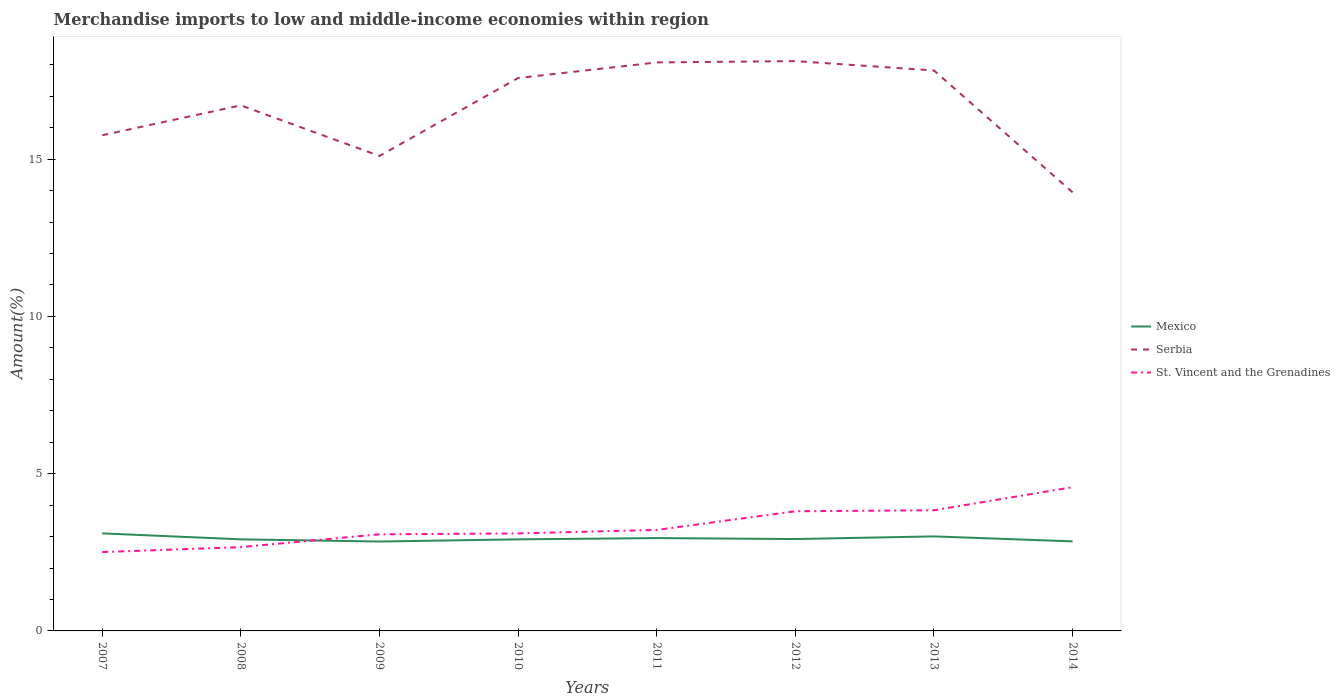Does the line corresponding to St. Vincent and the Grenadines intersect with the line corresponding to Serbia?
Your answer should be compact. No. Across all years, what is the maximum percentage of amount earned from merchandise imports in Serbia?
Your answer should be very brief. 13.95. In which year was the percentage of amount earned from merchandise imports in Serbia maximum?
Give a very brief answer. 2014. What is the total percentage of amount earned from merchandise imports in St. Vincent and the Grenadines in the graph?
Offer a terse response. -1.33. What is the difference between the highest and the second highest percentage of amount earned from merchandise imports in Serbia?
Your response must be concise. 4.17. What is the difference between the highest and the lowest percentage of amount earned from merchandise imports in Mexico?
Offer a terse response. 3. Is the percentage of amount earned from merchandise imports in St. Vincent and the Grenadines strictly greater than the percentage of amount earned from merchandise imports in Serbia over the years?
Provide a succinct answer. Yes. What is the difference between two consecutive major ticks on the Y-axis?
Your answer should be very brief. 5. Does the graph contain any zero values?
Make the answer very short. No. Where does the legend appear in the graph?
Keep it short and to the point. Center right. How many legend labels are there?
Ensure brevity in your answer.  3. How are the legend labels stacked?
Provide a succinct answer. Vertical. What is the title of the graph?
Your answer should be very brief. Merchandise imports to low and middle-income economies within region. What is the label or title of the X-axis?
Your response must be concise. Years. What is the label or title of the Y-axis?
Offer a terse response. Amount(%). What is the Amount(%) in Mexico in 2007?
Offer a very short reply. 3.1. What is the Amount(%) in Serbia in 2007?
Provide a short and direct response. 15.76. What is the Amount(%) of St. Vincent and the Grenadines in 2007?
Offer a terse response. 2.51. What is the Amount(%) in Mexico in 2008?
Provide a short and direct response. 2.91. What is the Amount(%) in Serbia in 2008?
Offer a very short reply. 16.71. What is the Amount(%) in St. Vincent and the Grenadines in 2008?
Provide a short and direct response. 2.66. What is the Amount(%) of Mexico in 2009?
Make the answer very short. 2.84. What is the Amount(%) in Serbia in 2009?
Provide a succinct answer. 15.1. What is the Amount(%) in St. Vincent and the Grenadines in 2009?
Make the answer very short. 3.07. What is the Amount(%) of Mexico in 2010?
Keep it short and to the point. 2.91. What is the Amount(%) in Serbia in 2010?
Make the answer very short. 17.58. What is the Amount(%) of St. Vincent and the Grenadines in 2010?
Keep it short and to the point. 3.1. What is the Amount(%) in Mexico in 2011?
Offer a very short reply. 2.95. What is the Amount(%) in Serbia in 2011?
Your answer should be compact. 18.07. What is the Amount(%) of St. Vincent and the Grenadines in 2011?
Offer a terse response. 3.21. What is the Amount(%) of Mexico in 2012?
Your answer should be compact. 2.92. What is the Amount(%) of Serbia in 2012?
Ensure brevity in your answer.  18.12. What is the Amount(%) in St. Vincent and the Grenadines in 2012?
Ensure brevity in your answer.  3.8. What is the Amount(%) in Mexico in 2013?
Offer a very short reply. 3.01. What is the Amount(%) of Serbia in 2013?
Your answer should be very brief. 17.82. What is the Amount(%) in St. Vincent and the Grenadines in 2013?
Your answer should be very brief. 3.84. What is the Amount(%) in Mexico in 2014?
Make the answer very short. 2.85. What is the Amount(%) in Serbia in 2014?
Keep it short and to the point. 13.95. What is the Amount(%) in St. Vincent and the Grenadines in 2014?
Ensure brevity in your answer.  4.57. Across all years, what is the maximum Amount(%) in Mexico?
Give a very brief answer. 3.1. Across all years, what is the maximum Amount(%) in Serbia?
Your answer should be compact. 18.12. Across all years, what is the maximum Amount(%) in St. Vincent and the Grenadines?
Your answer should be very brief. 4.57. Across all years, what is the minimum Amount(%) in Mexico?
Your response must be concise. 2.84. Across all years, what is the minimum Amount(%) of Serbia?
Give a very brief answer. 13.95. Across all years, what is the minimum Amount(%) in St. Vincent and the Grenadines?
Keep it short and to the point. 2.51. What is the total Amount(%) in Mexico in the graph?
Provide a short and direct response. 23.49. What is the total Amount(%) of Serbia in the graph?
Your answer should be compact. 133.1. What is the total Amount(%) in St. Vincent and the Grenadines in the graph?
Your answer should be very brief. 26.77. What is the difference between the Amount(%) of Mexico in 2007 and that in 2008?
Offer a terse response. 0.19. What is the difference between the Amount(%) of Serbia in 2007 and that in 2008?
Offer a terse response. -0.95. What is the difference between the Amount(%) of St. Vincent and the Grenadines in 2007 and that in 2008?
Make the answer very short. -0.16. What is the difference between the Amount(%) in Mexico in 2007 and that in 2009?
Your answer should be compact. 0.26. What is the difference between the Amount(%) of Serbia in 2007 and that in 2009?
Keep it short and to the point. 0.66. What is the difference between the Amount(%) in St. Vincent and the Grenadines in 2007 and that in 2009?
Give a very brief answer. -0.56. What is the difference between the Amount(%) in Mexico in 2007 and that in 2010?
Offer a terse response. 0.19. What is the difference between the Amount(%) of Serbia in 2007 and that in 2010?
Offer a very short reply. -1.82. What is the difference between the Amount(%) in St. Vincent and the Grenadines in 2007 and that in 2010?
Offer a very short reply. -0.59. What is the difference between the Amount(%) of Mexico in 2007 and that in 2011?
Your answer should be very brief. 0.15. What is the difference between the Amount(%) in Serbia in 2007 and that in 2011?
Give a very brief answer. -2.32. What is the difference between the Amount(%) of St. Vincent and the Grenadines in 2007 and that in 2011?
Your response must be concise. -0.7. What is the difference between the Amount(%) of Mexico in 2007 and that in 2012?
Keep it short and to the point. 0.18. What is the difference between the Amount(%) of Serbia in 2007 and that in 2012?
Provide a short and direct response. -2.36. What is the difference between the Amount(%) in St. Vincent and the Grenadines in 2007 and that in 2012?
Your answer should be compact. -1.3. What is the difference between the Amount(%) of Mexico in 2007 and that in 2013?
Make the answer very short. 0.1. What is the difference between the Amount(%) in Serbia in 2007 and that in 2013?
Your answer should be very brief. -2.06. What is the difference between the Amount(%) in St. Vincent and the Grenadines in 2007 and that in 2013?
Provide a succinct answer. -1.33. What is the difference between the Amount(%) in Mexico in 2007 and that in 2014?
Your response must be concise. 0.25. What is the difference between the Amount(%) in Serbia in 2007 and that in 2014?
Offer a very short reply. 1.81. What is the difference between the Amount(%) of St. Vincent and the Grenadines in 2007 and that in 2014?
Offer a very short reply. -2.06. What is the difference between the Amount(%) of Mexico in 2008 and that in 2009?
Make the answer very short. 0.07. What is the difference between the Amount(%) of Serbia in 2008 and that in 2009?
Provide a short and direct response. 1.61. What is the difference between the Amount(%) in St. Vincent and the Grenadines in 2008 and that in 2009?
Make the answer very short. -0.41. What is the difference between the Amount(%) of Mexico in 2008 and that in 2010?
Your answer should be very brief. -0. What is the difference between the Amount(%) of Serbia in 2008 and that in 2010?
Your response must be concise. -0.87. What is the difference between the Amount(%) in St. Vincent and the Grenadines in 2008 and that in 2010?
Provide a succinct answer. -0.44. What is the difference between the Amount(%) in Mexico in 2008 and that in 2011?
Keep it short and to the point. -0.04. What is the difference between the Amount(%) in Serbia in 2008 and that in 2011?
Your response must be concise. -1.37. What is the difference between the Amount(%) in St. Vincent and the Grenadines in 2008 and that in 2011?
Your response must be concise. -0.55. What is the difference between the Amount(%) of Mexico in 2008 and that in 2012?
Ensure brevity in your answer.  -0.01. What is the difference between the Amount(%) in Serbia in 2008 and that in 2012?
Your answer should be compact. -1.41. What is the difference between the Amount(%) of St. Vincent and the Grenadines in 2008 and that in 2012?
Your response must be concise. -1.14. What is the difference between the Amount(%) in Mexico in 2008 and that in 2013?
Provide a succinct answer. -0.09. What is the difference between the Amount(%) in Serbia in 2008 and that in 2013?
Offer a terse response. -1.11. What is the difference between the Amount(%) in St. Vincent and the Grenadines in 2008 and that in 2013?
Offer a terse response. -1.17. What is the difference between the Amount(%) of Mexico in 2008 and that in 2014?
Give a very brief answer. 0.06. What is the difference between the Amount(%) of Serbia in 2008 and that in 2014?
Offer a terse response. 2.76. What is the difference between the Amount(%) of St. Vincent and the Grenadines in 2008 and that in 2014?
Your answer should be very brief. -1.91. What is the difference between the Amount(%) in Mexico in 2009 and that in 2010?
Your response must be concise. -0.07. What is the difference between the Amount(%) in Serbia in 2009 and that in 2010?
Keep it short and to the point. -2.48. What is the difference between the Amount(%) in St. Vincent and the Grenadines in 2009 and that in 2010?
Your response must be concise. -0.03. What is the difference between the Amount(%) in Mexico in 2009 and that in 2011?
Offer a very short reply. -0.11. What is the difference between the Amount(%) of Serbia in 2009 and that in 2011?
Keep it short and to the point. -2.97. What is the difference between the Amount(%) in St. Vincent and the Grenadines in 2009 and that in 2011?
Ensure brevity in your answer.  -0.14. What is the difference between the Amount(%) in Mexico in 2009 and that in 2012?
Make the answer very short. -0.08. What is the difference between the Amount(%) of Serbia in 2009 and that in 2012?
Provide a succinct answer. -3.01. What is the difference between the Amount(%) of St. Vincent and the Grenadines in 2009 and that in 2012?
Your answer should be compact. -0.73. What is the difference between the Amount(%) in Mexico in 2009 and that in 2013?
Provide a succinct answer. -0.16. What is the difference between the Amount(%) of Serbia in 2009 and that in 2013?
Ensure brevity in your answer.  -2.72. What is the difference between the Amount(%) in St. Vincent and the Grenadines in 2009 and that in 2013?
Provide a short and direct response. -0.76. What is the difference between the Amount(%) of Mexico in 2009 and that in 2014?
Ensure brevity in your answer.  -0.01. What is the difference between the Amount(%) of Serbia in 2009 and that in 2014?
Give a very brief answer. 1.16. What is the difference between the Amount(%) in St. Vincent and the Grenadines in 2009 and that in 2014?
Provide a short and direct response. -1.5. What is the difference between the Amount(%) of Mexico in 2010 and that in 2011?
Keep it short and to the point. -0.04. What is the difference between the Amount(%) in Serbia in 2010 and that in 2011?
Give a very brief answer. -0.5. What is the difference between the Amount(%) in St. Vincent and the Grenadines in 2010 and that in 2011?
Ensure brevity in your answer.  -0.11. What is the difference between the Amount(%) of Mexico in 2010 and that in 2012?
Your response must be concise. -0.01. What is the difference between the Amount(%) of Serbia in 2010 and that in 2012?
Provide a succinct answer. -0.54. What is the difference between the Amount(%) in St. Vincent and the Grenadines in 2010 and that in 2012?
Offer a very short reply. -0.7. What is the difference between the Amount(%) of Mexico in 2010 and that in 2013?
Provide a succinct answer. -0.09. What is the difference between the Amount(%) of Serbia in 2010 and that in 2013?
Make the answer very short. -0.24. What is the difference between the Amount(%) of St. Vincent and the Grenadines in 2010 and that in 2013?
Offer a terse response. -0.74. What is the difference between the Amount(%) of Mexico in 2010 and that in 2014?
Provide a succinct answer. 0.06. What is the difference between the Amount(%) of Serbia in 2010 and that in 2014?
Provide a succinct answer. 3.63. What is the difference between the Amount(%) in St. Vincent and the Grenadines in 2010 and that in 2014?
Keep it short and to the point. -1.47. What is the difference between the Amount(%) in Mexico in 2011 and that in 2012?
Offer a very short reply. 0.03. What is the difference between the Amount(%) in Serbia in 2011 and that in 2012?
Your response must be concise. -0.04. What is the difference between the Amount(%) in St. Vincent and the Grenadines in 2011 and that in 2012?
Your answer should be compact. -0.59. What is the difference between the Amount(%) of Mexico in 2011 and that in 2013?
Your response must be concise. -0.05. What is the difference between the Amount(%) in Serbia in 2011 and that in 2013?
Offer a very short reply. 0.26. What is the difference between the Amount(%) in St. Vincent and the Grenadines in 2011 and that in 2013?
Provide a succinct answer. -0.63. What is the difference between the Amount(%) of Mexico in 2011 and that in 2014?
Provide a succinct answer. 0.1. What is the difference between the Amount(%) in Serbia in 2011 and that in 2014?
Offer a terse response. 4.13. What is the difference between the Amount(%) of St. Vincent and the Grenadines in 2011 and that in 2014?
Make the answer very short. -1.36. What is the difference between the Amount(%) in Mexico in 2012 and that in 2013?
Ensure brevity in your answer.  -0.08. What is the difference between the Amount(%) of Serbia in 2012 and that in 2013?
Your answer should be very brief. 0.3. What is the difference between the Amount(%) of St. Vincent and the Grenadines in 2012 and that in 2013?
Keep it short and to the point. -0.03. What is the difference between the Amount(%) in Mexico in 2012 and that in 2014?
Your answer should be compact. 0.07. What is the difference between the Amount(%) of Serbia in 2012 and that in 2014?
Your answer should be very brief. 4.17. What is the difference between the Amount(%) of St. Vincent and the Grenadines in 2012 and that in 2014?
Keep it short and to the point. -0.77. What is the difference between the Amount(%) of Mexico in 2013 and that in 2014?
Make the answer very short. 0.16. What is the difference between the Amount(%) in Serbia in 2013 and that in 2014?
Your response must be concise. 3.87. What is the difference between the Amount(%) of St. Vincent and the Grenadines in 2013 and that in 2014?
Provide a succinct answer. -0.73. What is the difference between the Amount(%) in Mexico in 2007 and the Amount(%) in Serbia in 2008?
Your answer should be very brief. -13.61. What is the difference between the Amount(%) of Mexico in 2007 and the Amount(%) of St. Vincent and the Grenadines in 2008?
Make the answer very short. 0.44. What is the difference between the Amount(%) of Serbia in 2007 and the Amount(%) of St. Vincent and the Grenadines in 2008?
Ensure brevity in your answer.  13.09. What is the difference between the Amount(%) of Mexico in 2007 and the Amount(%) of Serbia in 2009?
Ensure brevity in your answer.  -12. What is the difference between the Amount(%) of Mexico in 2007 and the Amount(%) of St. Vincent and the Grenadines in 2009?
Your answer should be very brief. 0.03. What is the difference between the Amount(%) in Serbia in 2007 and the Amount(%) in St. Vincent and the Grenadines in 2009?
Your answer should be compact. 12.69. What is the difference between the Amount(%) of Mexico in 2007 and the Amount(%) of Serbia in 2010?
Offer a terse response. -14.48. What is the difference between the Amount(%) in Mexico in 2007 and the Amount(%) in St. Vincent and the Grenadines in 2010?
Offer a terse response. 0. What is the difference between the Amount(%) in Serbia in 2007 and the Amount(%) in St. Vincent and the Grenadines in 2010?
Provide a short and direct response. 12.66. What is the difference between the Amount(%) in Mexico in 2007 and the Amount(%) in Serbia in 2011?
Ensure brevity in your answer.  -14.97. What is the difference between the Amount(%) of Mexico in 2007 and the Amount(%) of St. Vincent and the Grenadines in 2011?
Make the answer very short. -0.11. What is the difference between the Amount(%) in Serbia in 2007 and the Amount(%) in St. Vincent and the Grenadines in 2011?
Ensure brevity in your answer.  12.55. What is the difference between the Amount(%) in Mexico in 2007 and the Amount(%) in Serbia in 2012?
Ensure brevity in your answer.  -15.01. What is the difference between the Amount(%) of Mexico in 2007 and the Amount(%) of St. Vincent and the Grenadines in 2012?
Provide a short and direct response. -0.7. What is the difference between the Amount(%) in Serbia in 2007 and the Amount(%) in St. Vincent and the Grenadines in 2012?
Provide a succinct answer. 11.96. What is the difference between the Amount(%) in Mexico in 2007 and the Amount(%) in Serbia in 2013?
Make the answer very short. -14.72. What is the difference between the Amount(%) in Mexico in 2007 and the Amount(%) in St. Vincent and the Grenadines in 2013?
Provide a short and direct response. -0.74. What is the difference between the Amount(%) of Serbia in 2007 and the Amount(%) of St. Vincent and the Grenadines in 2013?
Provide a short and direct response. 11.92. What is the difference between the Amount(%) in Mexico in 2007 and the Amount(%) in Serbia in 2014?
Offer a very short reply. -10.84. What is the difference between the Amount(%) in Mexico in 2007 and the Amount(%) in St. Vincent and the Grenadines in 2014?
Your response must be concise. -1.47. What is the difference between the Amount(%) in Serbia in 2007 and the Amount(%) in St. Vincent and the Grenadines in 2014?
Provide a short and direct response. 11.19. What is the difference between the Amount(%) of Mexico in 2008 and the Amount(%) of Serbia in 2009?
Your answer should be compact. -12.19. What is the difference between the Amount(%) of Mexico in 2008 and the Amount(%) of St. Vincent and the Grenadines in 2009?
Provide a succinct answer. -0.16. What is the difference between the Amount(%) in Serbia in 2008 and the Amount(%) in St. Vincent and the Grenadines in 2009?
Keep it short and to the point. 13.64. What is the difference between the Amount(%) of Mexico in 2008 and the Amount(%) of Serbia in 2010?
Your answer should be compact. -14.67. What is the difference between the Amount(%) in Mexico in 2008 and the Amount(%) in St. Vincent and the Grenadines in 2010?
Offer a very short reply. -0.19. What is the difference between the Amount(%) of Serbia in 2008 and the Amount(%) of St. Vincent and the Grenadines in 2010?
Your answer should be very brief. 13.61. What is the difference between the Amount(%) in Mexico in 2008 and the Amount(%) in Serbia in 2011?
Offer a very short reply. -15.16. What is the difference between the Amount(%) of Mexico in 2008 and the Amount(%) of St. Vincent and the Grenadines in 2011?
Give a very brief answer. -0.3. What is the difference between the Amount(%) in Serbia in 2008 and the Amount(%) in St. Vincent and the Grenadines in 2011?
Make the answer very short. 13.5. What is the difference between the Amount(%) of Mexico in 2008 and the Amount(%) of Serbia in 2012?
Offer a very short reply. -15.2. What is the difference between the Amount(%) in Mexico in 2008 and the Amount(%) in St. Vincent and the Grenadines in 2012?
Provide a short and direct response. -0.89. What is the difference between the Amount(%) of Serbia in 2008 and the Amount(%) of St. Vincent and the Grenadines in 2012?
Your answer should be very brief. 12.9. What is the difference between the Amount(%) of Mexico in 2008 and the Amount(%) of Serbia in 2013?
Offer a terse response. -14.91. What is the difference between the Amount(%) of Mexico in 2008 and the Amount(%) of St. Vincent and the Grenadines in 2013?
Ensure brevity in your answer.  -0.93. What is the difference between the Amount(%) in Serbia in 2008 and the Amount(%) in St. Vincent and the Grenadines in 2013?
Ensure brevity in your answer.  12.87. What is the difference between the Amount(%) in Mexico in 2008 and the Amount(%) in Serbia in 2014?
Provide a succinct answer. -11.03. What is the difference between the Amount(%) in Mexico in 2008 and the Amount(%) in St. Vincent and the Grenadines in 2014?
Make the answer very short. -1.66. What is the difference between the Amount(%) of Serbia in 2008 and the Amount(%) of St. Vincent and the Grenadines in 2014?
Provide a short and direct response. 12.14. What is the difference between the Amount(%) of Mexico in 2009 and the Amount(%) of Serbia in 2010?
Keep it short and to the point. -14.74. What is the difference between the Amount(%) in Mexico in 2009 and the Amount(%) in St. Vincent and the Grenadines in 2010?
Offer a very short reply. -0.26. What is the difference between the Amount(%) in Serbia in 2009 and the Amount(%) in St. Vincent and the Grenadines in 2010?
Ensure brevity in your answer.  12. What is the difference between the Amount(%) of Mexico in 2009 and the Amount(%) of Serbia in 2011?
Ensure brevity in your answer.  -15.23. What is the difference between the Amount(%) of Mexico in 2009 and the Amount(%) of St. Vincent and the Grenadines in 2011?
Make the answer very short. -0.37. What is the difference between the Amount(%) in Serbia in 2009 and the Amount(%) in St. Vincent and the Grenadines in 2011?
Provide a succinct answer. 11.89. What is the difference between the Amount(%) of Mexico in 2009 and the Amount(%) of Serbia in 2012?
Offer a terse response. -15.27. What is the difference between the Amount(%) in Mexico in 2009 and the Amount(%) in St. Vincent and the Grenadines in 2012?
Offer a terse response. -0.96. What is the difference between the Amount(%) in Serbia in 2009 and the Amount(%) in St. Vincent and the Grenadines in 2012?
Your answer should be compact. 11.3. What is the difference between the Amount(%) of Mexico in 2009 and the Amount(%) of Serbia in 2013?
Your response must be concise. -14.98. What is the difference between the Amount(%) of Mexico in 2009 and the Amount(%) of St. Vincent and the Grenadines in 2013?
Provide a succinct answer. -0.99. What is the difference between the Amount(%) of Serbia in 2009 and the Amount(%) of St. Vincent and the Grenadines in 2013?
Keep it short and to the point. 11.26. What is the difference between the Amount(%) of Mexico in 2009 and the Amount(%) of Serbia in 2014?
Your response must be concise. -11.1. What is the difference between the Amount(%) in Mexico in 2009 and the Amount(%) in St. Vincent and the Grenadines in 2014?
Your answer should be very brief. -1.73. What is the difference between the Amount(%) in Serbia in 2009 and the Amount(%) in St. Vincent and the Grenadines in 2014?
Keep it short and to the point. 10.53. What is the difference between the Amount(%) of Mexico in 2010 and the Amount(%) of Serbia in 2011?
Offer a very short reply. -15.16. What is the difference between the Amount(%) of Mexico in 2010 and the Amount(%) of St. Vincent and the Grenadines in 2011?
Provide a short and direct response. -0.3. What is the difference between the Amount(%) in Serbia in 2010 and the Amount(%) in St. Vincent and the Grenadines in 2011?
Ensure brevity in your answer.  14.37. What is the difference between the Amount(%) of Mexico in 2010 and the Amount(%) of Serbia in 2012?
Provide a short and direct response. -15.2. What is the difference between the Amount(%) in Mexico in 2010 and the Amount(%) in St. Vincent and the Grenadines in 2012?
Make the answer very short. -0.89. What is the difference between the Amount(%) in Serbia in 2010 and the Amount(%) in St. Vincent and the Grenadines in 2012?
Keep it short and to the point. 13.77. What is the difference between the Amount(%) in Mexico in 2010 and the Amount(%) in Serbia in 2013?
Your answer should be compact. -14.91. What is the difference between the Amount(%) of Mexico in 2010 and the Amount(%) of St. Vincent and the Grenadines in 2013?
Provide a succinct answer. -0.93. What is the difference between the Amount(%) of Serbia in 2010 and the Amount(%) of St. Vincent and the Grenadines in 2013?
Your answer should be compact. 13.74. What is the difference between the Amount(%) of Mexico in 2010 and the Amount(%) of Serbia in 2014?
Offer a terse response. -11.03. What is the difference between the Amount(%) in Mexico in 2010 and the Amount(%) in St. Vincent and the Grenadines in 2014?
Offer a terse response. -1.66. What is the difference between the Amount(%) of Serbia in 2010 and the Amount(%) of St. Vincent and the Grenadines in 2014?
Your answer should be compact. 13.01. What is the difference between the Amount(%) of Mexico in 2011 and the Amount(%) of Serbia in 2012?
Provide a succinct answer. -15.16. What is the difference between the Amount(%) in Mexico in 2011 and the Amount(%) in St. Vincent and the Grenadines in 2012?
Offer a terse response. -0.85. What is the difference between the Amount(%) of Serbia in 2011 and the Amount(%) of St. Vincent and the Grenadines in 2012?
Your answer should be compact. 14.27. What is the difference between the Amount(%) of Mexico in 2011 and the Amount(%) of Serbia in 2013?
Offer a terse response. -14.87. What is the difference between the Amount(%) in Mexico in 2011 and the Amount(%) in St. Vincent and the Grenadines in 2013?
Offer a terse response. -0.89. What is the difference between the Amount(%) of Serbia in 2011 and the Amount(%) of St. Vincent and the Grenadines in 2013?
Your answer should be compact. 14.24. What is the difference between the Amount(%) in Mexico in 2011 and the Amount(%) in Serbia in 2014?
Make the answer very short. -10.99. What is the difference between the Amount(%) in Mexico in 2011 and the Amount(%) in St. Vincent and the Grenadines in 2014?
Offer a very short reply. -1.62. What is the difference between the Amount(%) of Serbia in 2011 and the Amount(%) of St. Vincent and the Grenadines in 2014?
Your answer should be very brief. 13.5. What is the difference between the Amount(%) in Mexico in 2012 and the Amount(%) in Serbia in 2013?
Give a very brief answer. -14.9. What is the difference between the Amount(%) in Mexico in 2012 and the Amount(%) in St. Vincent and the Grenadines in 2013?
Offer a terse response. -0.92. What is the difference between the Amount(%) of Serbia in 2012 and the Amount(%) of St. Vincent and the Grenadines in 2013?
Offer a very short reply. 14.28. What is the difference between the Amount(%) in Mexico in 2012 and the Amount(%) in Serbia in 2014?
Offer a very short reply. -11.02. What is the difference between the Amount(%) of Mexico in 2012 and the Amount(%) of St. Vincent and the Grenadines in 2014?
Make the answer very short. -1.65. What is the difference between the Amount(%) of Serbia in 2012 and the Amount(%) of St. Vincent and the Grenadines in 2014?
Your answer should be compact. 13.55. What is the difference between the Amount(%) in Mexico in 2013 and the Amount(%) in Serbia in 2014?
Ensure brevity in your answer.  -10.94. What is the difference between the Amount(%) of Mexico in 2013 and the Amount(%) of St. Vincent and the Grenadines in 2014?
Make the answer very short. -1.56. What is the difference between the Amount(%) in Serbia in 2013 and the Amount(%) in St. Vincent and the Grenadines in 2014?
Provide a succinct answer. 13.25. What is the average Amount(%) of Mexico per year?
Give a very brief answer. 2.94. What is the average Amount(%) in Serbia per year?
Offer a terse response. 16.64. What is the average Amount(%) in St. Vincent and the Grenadines per year?
Provide a succinct answer. 3.35. In the year 2007, what is the difference between the Amount(%) in Mexico and Amount(%) in Serbia?
Keep it short and to the point. -12.66. In the year 2007, what is the difference between the Amount(%) of Mexico and Amount(%) of St. Vincent and the Grenadines?
Your answer should be very brief. 0.59. In the year 2007, what is the difference between the Amount(%) of Serbia and Amount(%) of St. Vincent and the Grenadines?
Ensure brevity in your answer.  13.25. In the year 2008, what is the difference between the Amount(%) of Mexico and Amount(%) of Serbia?
Your answer should be compact. -13.8. In the year 2008, what is the difference between the Amount(%) of Mexico and Amount(%) of St. Vincent and the Grenadines?
Provide a succinct answer. 0.25. In the year 2008, what is the difference between the Amount(%) in Serbia and Amount(%) in St. Vincent and the Grenadines?
Provide a short and direct response. 14.04. In the year 2009, what is the difference between the Amount(%) in Mexico and Amount(%) in Serbia?
Your answer should be very brief. -12.26. In the year 2009, what is the difference between the Amount(%) in Mexico and Amount(%) in St. Vincent and the Grenadines?
Keep it short and to the point. -0.23. In the year 2009, what is the difference between the Amount(%) in Serbia and Amount(%) in St. Vincent and the Grenadines?
Provide a short and direct response. 12.03. In the year 2010, what is the difference between the Amount(%) in Mexico and Amount(%) in Serbia?
Make the answer very short. -14.67. In the year 2010, what is the difference between the Amount(%) of Mexico and Amount(%) of St. Vincent and the Grenadines?
Your response must be concise. -0.19. In the year 2010, what is the difference between the Amount(%) of Serbia and Amount(%) of St. Vincent and the Grenadines?
Keep it short and to the point. 14.48. In the year 2011, what is the difference between the Amount(%) of Mexico and Amount(%) of Serbia?
Offer a terse response. -15.12. In the year 2011, what is the difference between the Amount(%) of Mexico and Amount(%) of St. Vincent and the Grenadines?
Provide a short and direct response. -0.26. In the year 2011, what is the difference between the Amount(%) in Serbia and Amount(%) in St. Vincent and the Grenadines?
Provide a short and direct response. 14.86. In the year 2012, what is the difference between the Amount(%) of Mexico and Amount(%) of Serbia?
Your response must be concise. -15.2. In the year 2012, what is the difference between the Amount(%) of Mexico and Amount(%) of St. Vincent and the Grenadines?
Make the answer very short. -0.88. In the year 2012, what is the difference between the Amount(%) in Serbia and Amount(%) in St. Vincent and the Grenadines?
Ensure brevity in your answer.  14.31. In the year 2013, what is the difference between the Amount(%) of Mexico and Amount(%) of Serbia?
Keep it short and to the point. -14.81. In the year 2013, what is the difference between the Amount(%) of Mexico and Amount(%) of St. Vincent and the Grenadines?
Provide a short and direct response. -0.83. In the year 2013, what is the difference between the Amount(%) of Serbia and Amount(%) of St. Vincent and the Grenadines?
Keep it short and to the point. 13.98. In the year 2014, what is the difference between the Amount(%) in Mexico and Amount(%) in Serbia?
Provide a short and direct response. -11.1. In the year 2014, what is the difference between the Amount(%) in Mexico and Amount(%) in St. Vincent and the Grenadines?
Offer a terse response. -1.72. In the year 2014, what is the difference between the Amount(%) in Serbia and Amount(%) in St. Vincent and the Grenadines?
Your answer should be compact. 9.38. What is the ratio of the Amount(%) in Mexico in 2007 to that in 2008?
Your response must be concise. 1.07. What is the ratio of the Amount(%) in Serbia in 2007 to that in 2008?
Provide a succinct answer. 0.94. What is the ratio of the Amount(%) in St. Vincent and the Grenadines in 2007 to that in 2008?
Provide a short and direct response. 0.94. What is the ratio of the Amount(%) in Mexico in 2007 to that in 2009?
Keep it short and to the point. 1.09. What is the ratio of the Amount(%) of Serbia in 2007 to that in 2009?
Offer a terse response. 1.04. What is the ratio of the Amount(%) of St. Vincent and the Grenadines in 2007 to that in 2009?
Your answer should be very brief. 0.82. What is the ratio of the Amount(%) of Mexico in 2007 to that in 2010?
Your response must be concise. 1.07. What is the ratio of the Amount(%) in Serbia in 2007 to that in 2010?
Make the answer very short. 0.9. What is the ratio of the Amount(%) in St. Vincent and the Grenadines in 2007 to that in 2010?
Provide a succinct answer. 0.81. What is the ratio of the Amount(%) of Mexico in 2007 to that in 2011?
Provide a short and direct response. 1.05. What is the ratio of the Amount(%) in Serbia in 2007 to that in 2011?
Offer a terse response. 0.87. What is the ratio of the Amount(%) in St. Vincent and the Grenadines in 2007 to that in 2011?
Provide a succinct answer. 0.78. What is the ratio of the Amount(%) in Mexico in 2007 to that in 2012?
Your answer should be very brief. 1.06. What is the ratio of the Amount(%) in Serbia in 2007 to that in 2012?
Ensure brevity in your answer.  0.87. What is the ratio of the Amount(%) in St. Vincent and the Grenadines in 2007 to that in 2012?
Give a very brief answer. 0.66. What is the ratio of the Amount(%) of Mexico in 2007 to that in 2013?
Provide a short and direct response. 1.03. What is the ratio of the Amount(%) in Serbia in 2007 to that in 2013?
Ensure brevity in your answer.  0.88. What is the ratio of the Amount(%) of St. Vincent and the Grenadines in 2007 to that in 2013?
Your answer should be compact. 0.65. What is the ratio of the Amount(%) of Mexico in 2007 to that in 2014?
Your answer should be very brief. 1.09. What is the ratio of the Amount(%) in Serbia in 2007 to that in 2014?
Ensure brevity in your answer.  1.13. What is the ratio of the Amount(%) of St. Vincent and the Grenadines in 2007 to that in 2014?
Your response must be concise. 0.55. What is the ratio of the Amount(%) in Mexico in 2008 to that in 2009?
Ensure brevity in your answer.  1.02. What is the ratio of the Amount(%) in Serbia in 2008 to that in 2009?
Your answer should be compact. 1.11. What is the ratio of the Amount(%) in St. Vincent and the Grenadines in 2008 to that in 2009?
Keep it short and to the point. 0.87. What is the ratio of the Amount(%) in Mexico in 2008 to that in 2010?
Your answer should be compact. 1. What is the ratio of the Amount(%) in Serbia in 2008 to that in 2010?
Ensure brevity in your answer.  0.95. What is the ratio of the Amount(%) in St. Vincent and the Grenadines in 2008 to that in 2010?
Offer a very short reply. 0.86. What is the ratio of the Amount(%) in Mexico in 2008 to that in 2011?
Give a very brief answer. 0.99. What is the ratio of the Amount(%) of Serbia in 2008 to that in 2011?
Keep it short and to the point. 0.92. What is the ratio of the Amount(%) of St. Vincent and the Grenadines in 2008 to that in 2011?
Give a very brief answer. 0.83. What is the ratio of the Amount(%) of Serbia in 2008 to that in 2012?
Your response must be concise. 0.92. What is the ratio of the Amount(%) in St. Vincent and the Grenadines in 2008 to that in 2012?
Your answer should be compact. 0.7. What is the ratio of the Amount(%) in Mexico in 2008 to that in 2013?
Offer a terse response. 0.97. What is the ratio of the Amount(%) of Serbia in 2008 to that in 2013?
Your answer should be very brief. 0.94. What is the ratio of the Amount(%) in St. Vincent and the Grenadines in 2008 to that in 2013?
Ensure brevity in your answer.  0.69. What is the ratio of the Amount(%) of Mexico in 2008 to that in 2014?
Keep it short and to the point. 1.02. What is the ratio of the Amount(%) of Serbia in 2008 to that in 2014?
Your response must be concise. 1.2. What is the ratio of the Amount(%) of St. Vincent and the Grenadines in 2008 to that in 2014?
Your response must be concise. 0.58. What is the ratio of the Amount(%) in Mexico in 2009 to that in 2010?
Your answer should be very brief. 0.98. What is the ratio of the Amount(%) of Serbia in 2009 to that in 2010?
Offer a very short reply. 0.86. What is the ratio of the Amount(%) in Mexico in 2009 to that in 2011?
Provide a short and direct response. 0.96. What is the ratio of the Amount(%) in Serbia in 2009 to that in 2011?
Give a very brief answer. 0.84. What is the ratio of the Amount(%) in St. Vincent and the Grenadines in 2009 to that in 2011?
Ensure brevity in your answer.  0.96. What is the ratio of the Amount(%) in Serbia in 2009 to that in 2012?
Your answer should be very brief. 0.83. What is the ratio of the Amount(%) of St. Vincent and the Grenadines in 2009 to that in 2012?
Offer a terse response. 0.81. What is the ratio of the Amount(%) in Mexico in 2009 to that in 2013?
Provide a succinct answer. 0.95. What is the ratio of the Amount(%) of Serbia in 2009 to that in 2013?
Provide a succinct answer. 0.85. What is the ratio of the Amount(%) in St. Vincent and the Grenadines in 2009 to that in 2013?
Offer a terse response. 0.8. What is the ratio of the Amount(%) in Mexico in 2009 to that in 2014?
Ensure brevity in your answer.  1. What is the ratio of the Amount(%) of Serbia in 2009 to that in 2014?
Keep it short and to the point. 1.08. What is the ratio of the Amount(%) of St. Vincent and the Grenadines in 2009 to that in 2014?
Your answer should be compact. 0.67. What is the ratio of the Amount(%) in Mexico in 2010 to that in 2011?
Provide a short and direct response. 0.99. What is the ratio of the Amount(%) in Serbia in 2010 to that in 2011?
Make the answer very short. 0.97. What is the ratio of the Amount(%) of St. Vincent and the Grenadines in 2010 to that in 2011?
Ensure brevity in your answer.  0.97. What is the ratio of the Amount(%) in Serbia in 2010 to that in 2012?
Provide a short and direct response. 0.97. What is the ratio of the Amount(%) in St. Vincent and the Grenadines in 2010 to that in 2012?
Your answer should be compact. 0.81. What is the ratio of the Amount(%) of Mexico in 2010 to that in 2013?
Your response must be concise. 0.97. What is the ratio of the Amount(%) in Serbia in 2010 to that in 2013?
Ensure brevity in your answer.  0.99. What is the ratio of the Amount(%) of St. Vincent and the Grenadines in 2010 to that in 2013?
Offer a very short reply. 0.81. What is the ratio of the Amount(%) in Mexico in 2010 to that in 2014?
Your answer should be very brief. 1.02. What is the ratio of the Amount(%) in Serbia in 2010 to that in 2014?
Your response must be concise. 1.26. What is the ratio of the Amount(%) in St. Vincent and the Grenadines in 2010 to that in 2014?
Make the answer very short. 0.68. What is the ratio of the Amount(%) of Mexico in 2011 to that in 2012?
Give a very brief answer. 1.01. What is the ratio of the Amount(%) of Serbia in 2011 to that in 2012?
Offer a terse response. 1. What is the ratio of the Amount(%) of St. Vincent and the Grenadines in 2011 to that in 2012?
Keep it short and to the point. 0.84. What is the ratio of the Amount(%) of Mexico in 2011 to that in 2013?
Provide a short and direct response. 0.98. What is the ratio of the Amount(%) in Serbia in 2011 to that in 2013?
Provide a short and direct response. 1.01. What is the ratio of the Amount(%) in St. Vincent and the Grenadines in 2011 to that in 2013?
Provide a short and direct response. 0.84. What is the ratio of the Amount(%) in Mexico in 2011 to that in 2014?
Your answer should be compact. 1.04. What is the ratio of the Amount(%) in Serbia in 2011 to that in 2014?
Your response must be concise. 1.3. What is the ratio of the Amount(%) in St. Vincent and the Grenadines in 2011 to that in 2014?
Keep it short and to the point. 0.7. What is the ratio of the Amount(%) in Mexico in 2012 to that in 2013?
Provide a short and direct response. 0.97. What is the ratio of the Amount(%) in Serbia in 2012 to that in 2013?
Make the answer very short. 1.02. What is the ratio of the Amount(%) of Mexico in 2012 to that in 2014?
Ensure brevity in your answer.  1.03. What is the ratio of the Amount(%) in Serbia in 2012 to that in 2014?
Your answer should be compact. 1.3. What is the ratio of the Amount(%) in St. Vincent and the Grenadines in 2012 to that in 2014?
Give a very brief answer. 0.83. What is the ratio of the Amount(%) of Mexico in 2013 to that in 2014?
Your answer should be very brief. 1.06. What is the ratio of the Amount(%) in Serbia in 2013 to that in 2014?
Make the answer very short. 1.28. What is the ratio of the Amount(%) in St. Vincent and the Grenadines in 2013 to that in 2014?
Give a very brief answer. 0.84. What is the difference between the highest and the second highest Amount(%) of Mexico?
Provide a short and direct response. 0.1. What is the difference between the highest and the second highest Amount(%) in Serbia?
Offer a terse response. 0.04. What is the difference between the highest and the second highest Amount(%) in St. Vincent and the Grenadines?
Give a very brief answer. 0.73. What is the difference between the highest and the lowest Amount(%) in Mexico?
Provide a short and direct response. 0.26. What is the difference between the highest and the lowest Amount(%) of Serbia?
Offer a terse response. 4.17. What is the difference between the highest and the lowest Amount(%) in St. Vincent and the Grenadines?
Your response must be concise. 2.06. 